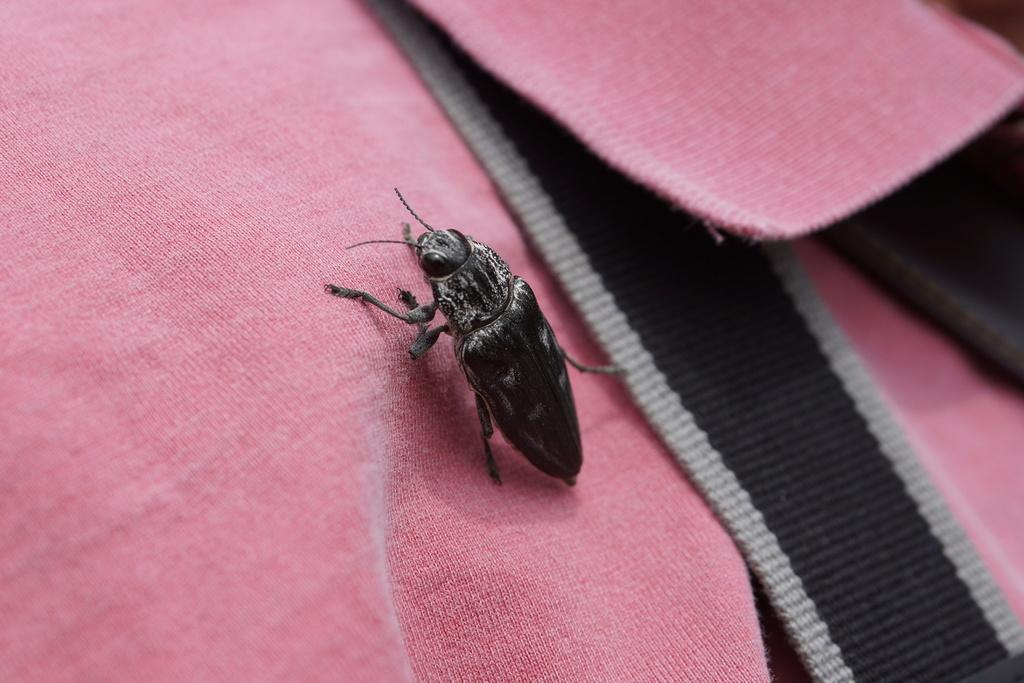What type of creature is present in the image? There is an insect in the image. What type of loaf is being held by the insect in the image? There is no loaf present in the image, and the insect is not holding anything. 